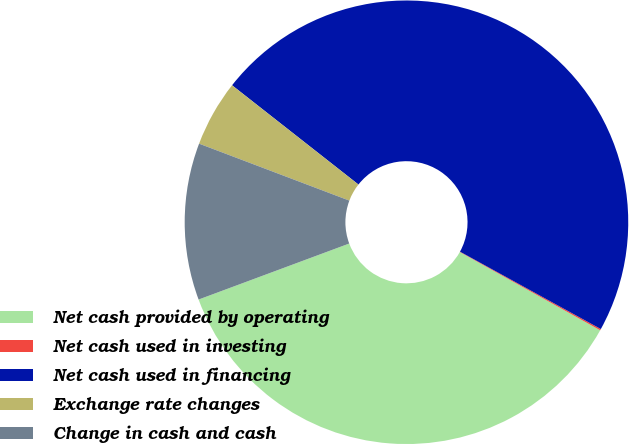Convert chart to OTSL. <chart><loc_0><loc_0><loc_500><loc_500><pie_chart><fcel>Net cash provided by operating<fcel>Net cash used in investing<fcel>Net cash used in financing<fcel>Exchange rate changes<fcel>Change in cash and cash<nl><fcel>36.24%<fcel>0.1%<fcel>47.4%<fcel>4.83%<fcel>11.43%<nl></chart> 